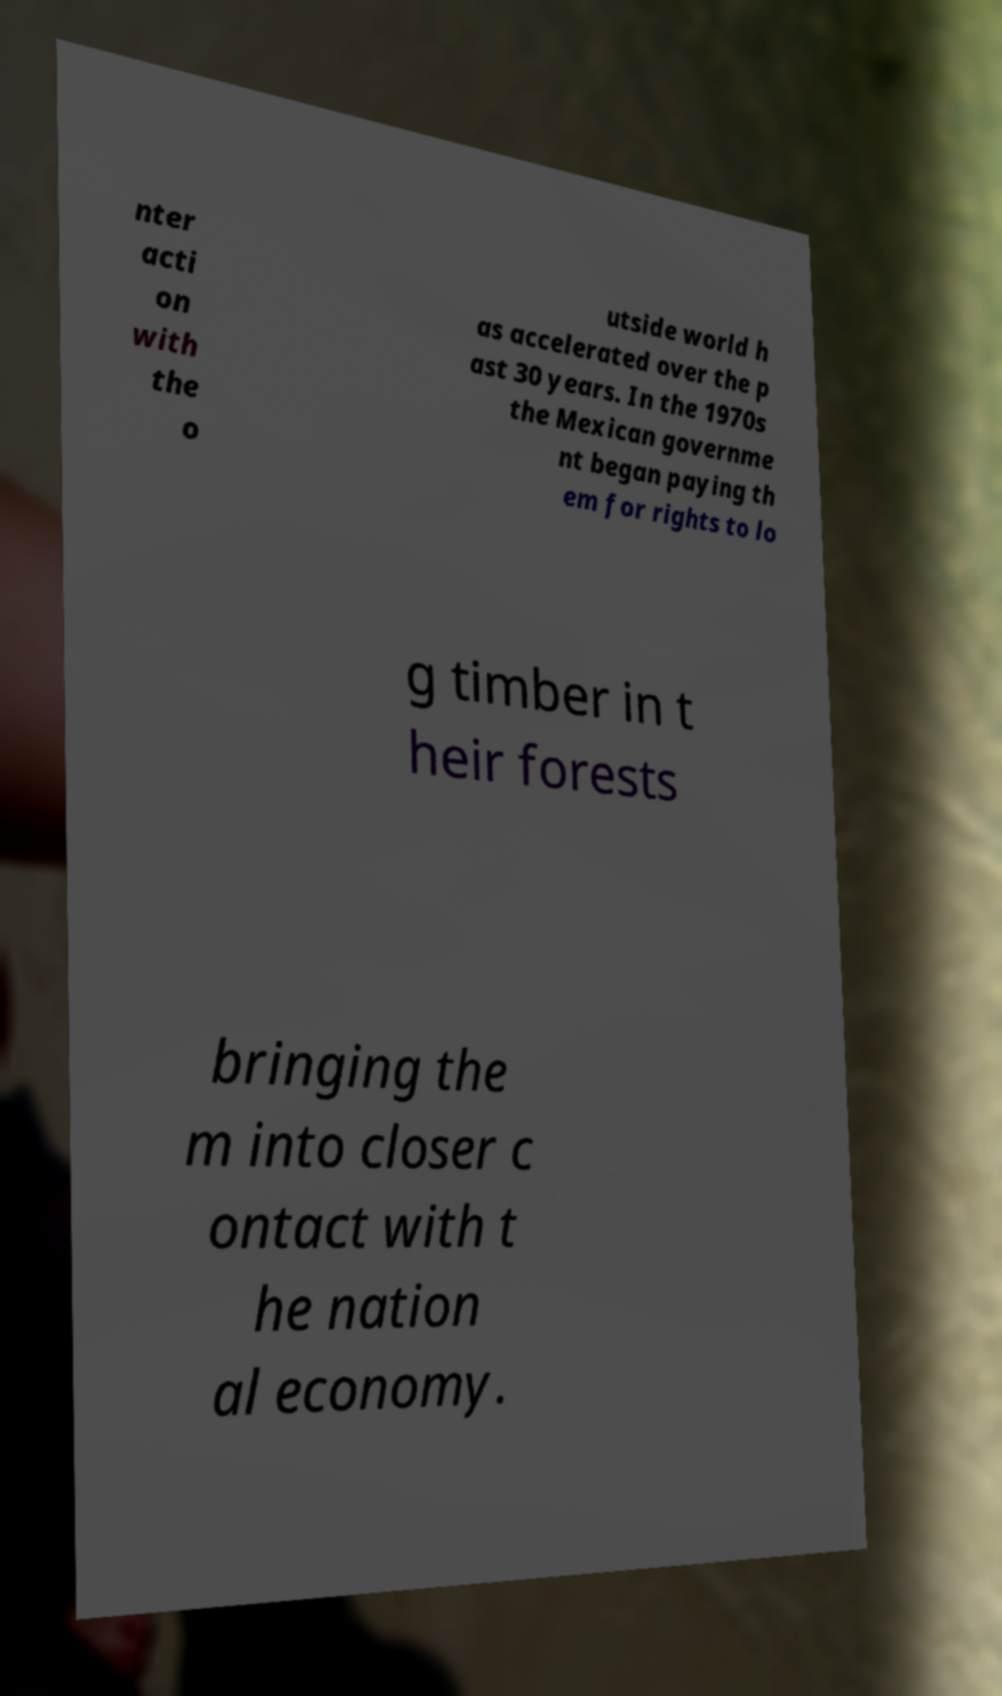There's text embedded in this image that I need extracted. Can you transcribe it verbatim? nter acti on with the o utside world h as accelerated over the p ast 30 years. In the 1970s the Mexican governme nt began paying th em for rights to lo g timber in t heir forests bringing the m into closer c ontact with t he nation al economy. 